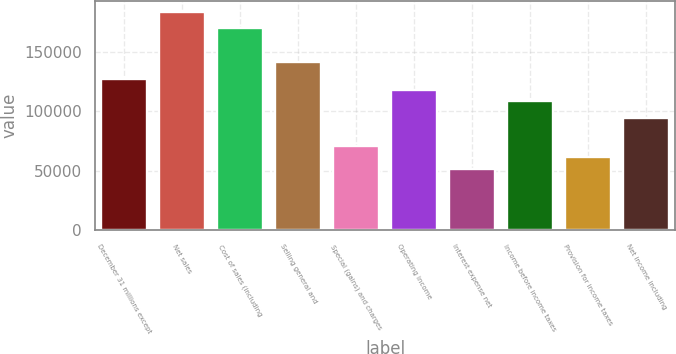Convert chart. <chart><loc_0><loc_0><loc_500><loc_500><bar_chart><fcel>December 31 millions except<fcel>Net sales<fcel>Cost of sales (including<fcel>Selling general and<fcel>Special (gains) and charges<fcel>Operating income<fcel>Interest expense net<fcel>Income before income taxes<fcel>Provision for income taxes<fcel>Net income including<nl><fcel>127289<fcel>183862<fcel>169719<fcel>141432<fcel>70716.9<fcel>117861<fcel>51859.4<fcel>108432<fcel>61288.2<fcel>94288.7<nl></chart> 